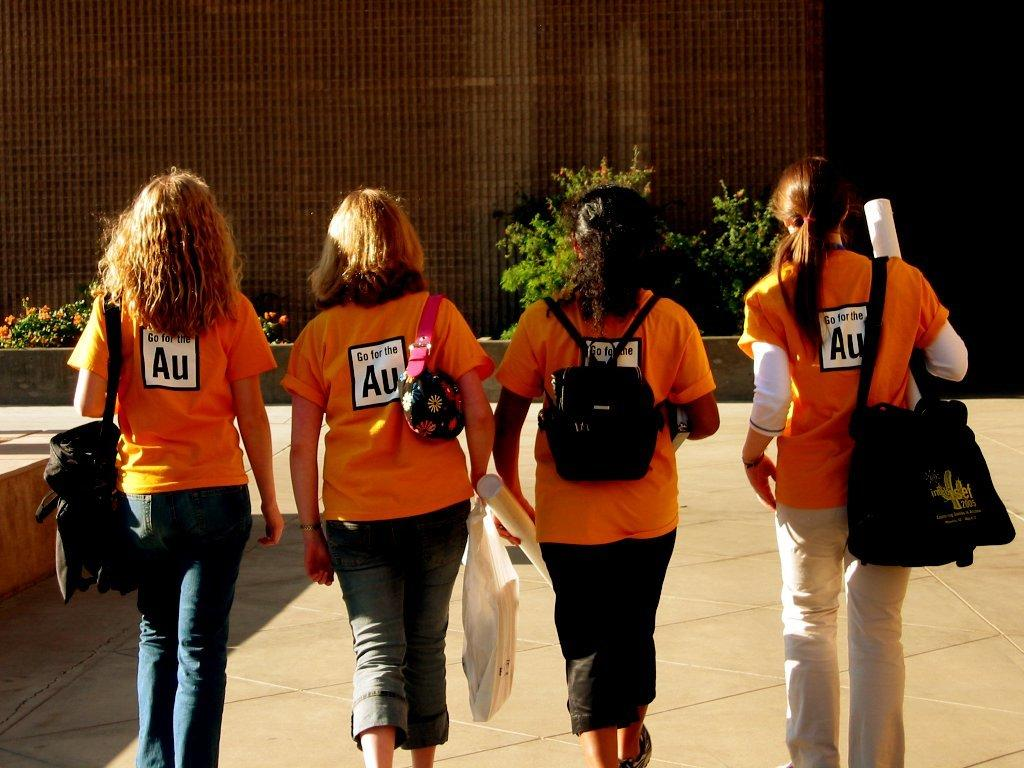Who or what can be seen in the image? There are people in the image. What else is present in the image besides people? There are objects in the image. What can be seen under the people's feet in the image? The ground is visible in the image. Are there any plants in the image? Yes, there are plants in the image. What is one of the features of the background in the image? There is a wall in the image. Where are the objects located in the image? The objects are on the left side of the image. What type of silk is being used to write on the quill in the image? There is no silk or quill present in the image. What flavor of cake can be seen in the image? There is no cake present in the image. 